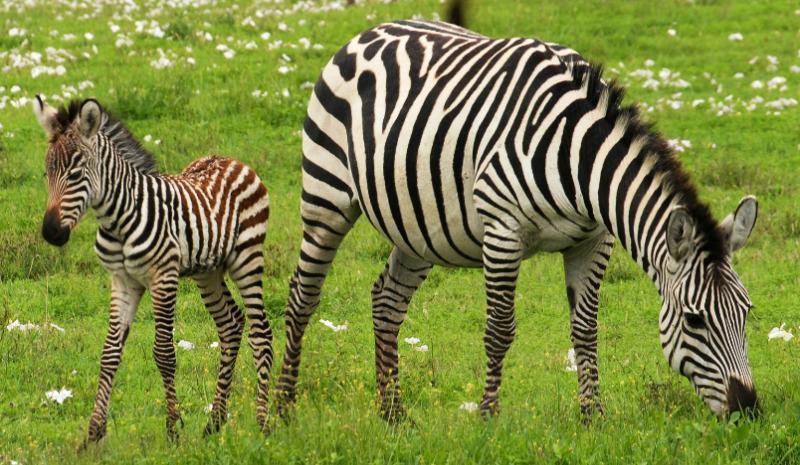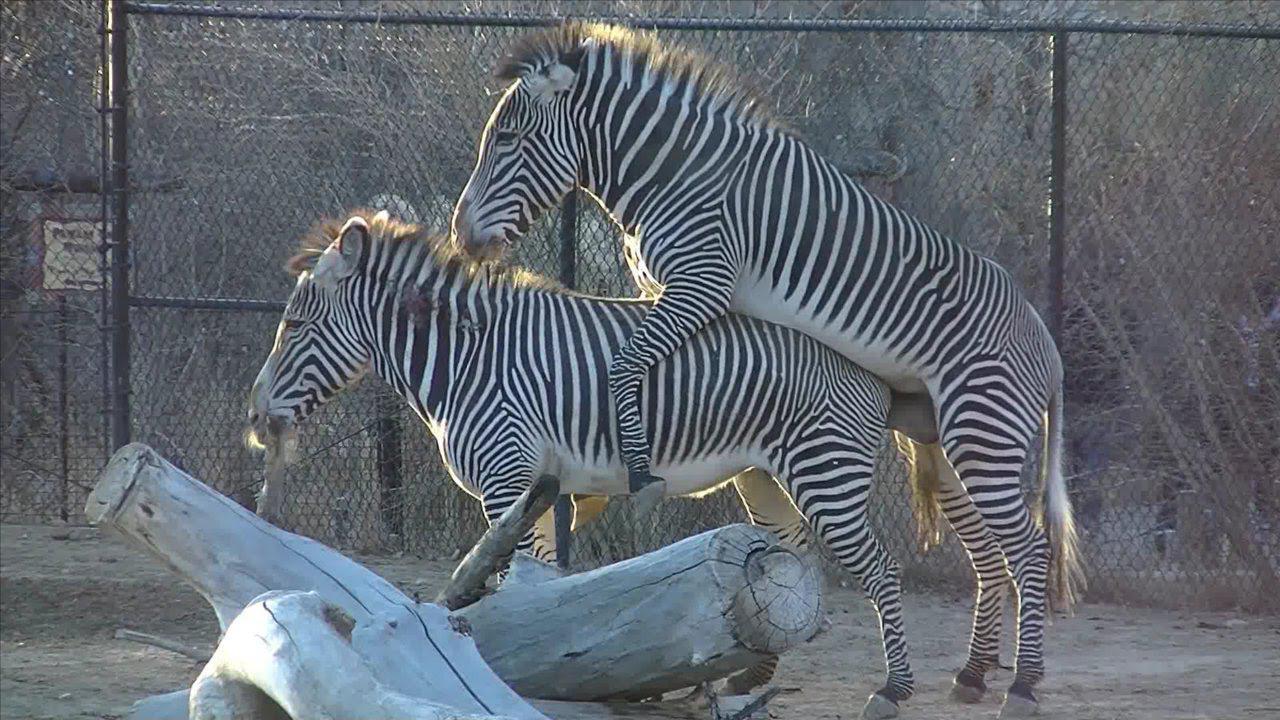The first image is the image on the left, the second image is the image on the right. Considering the images on both sides, is "The left image shows a smaller hooved animal next to a bigger hooved animal, and the right image shows one zebra with its front legs over another zebra's back." valid? Answer yes or no. Yes. The first image is the image on the left, the second image is the image on the right. Evaluate the accuracy of this statement regarding the images: "The left and right image contains the same number of adult zebras.". Is it true? Answer yes or no. No. 